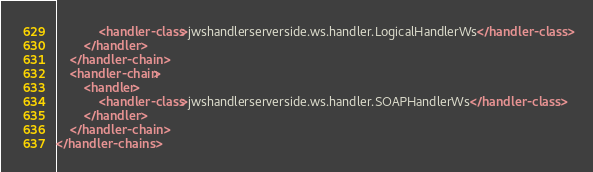<code> <loc_0><loc_0><loc_500><loc_500><_XML_>            <handler-class>jwshandlerserverside.ws.handler.LogicalHandlerWs</handler-class>
        </handler>
    </handler-chain>
    <handler-chain>
        <handler>
            <handler-class>jwshandlerserverside.ws.handler.SOAPHandlerWs</handler-class>
        </handler>
    </handler-chain>
</handler-chains>
</code> 